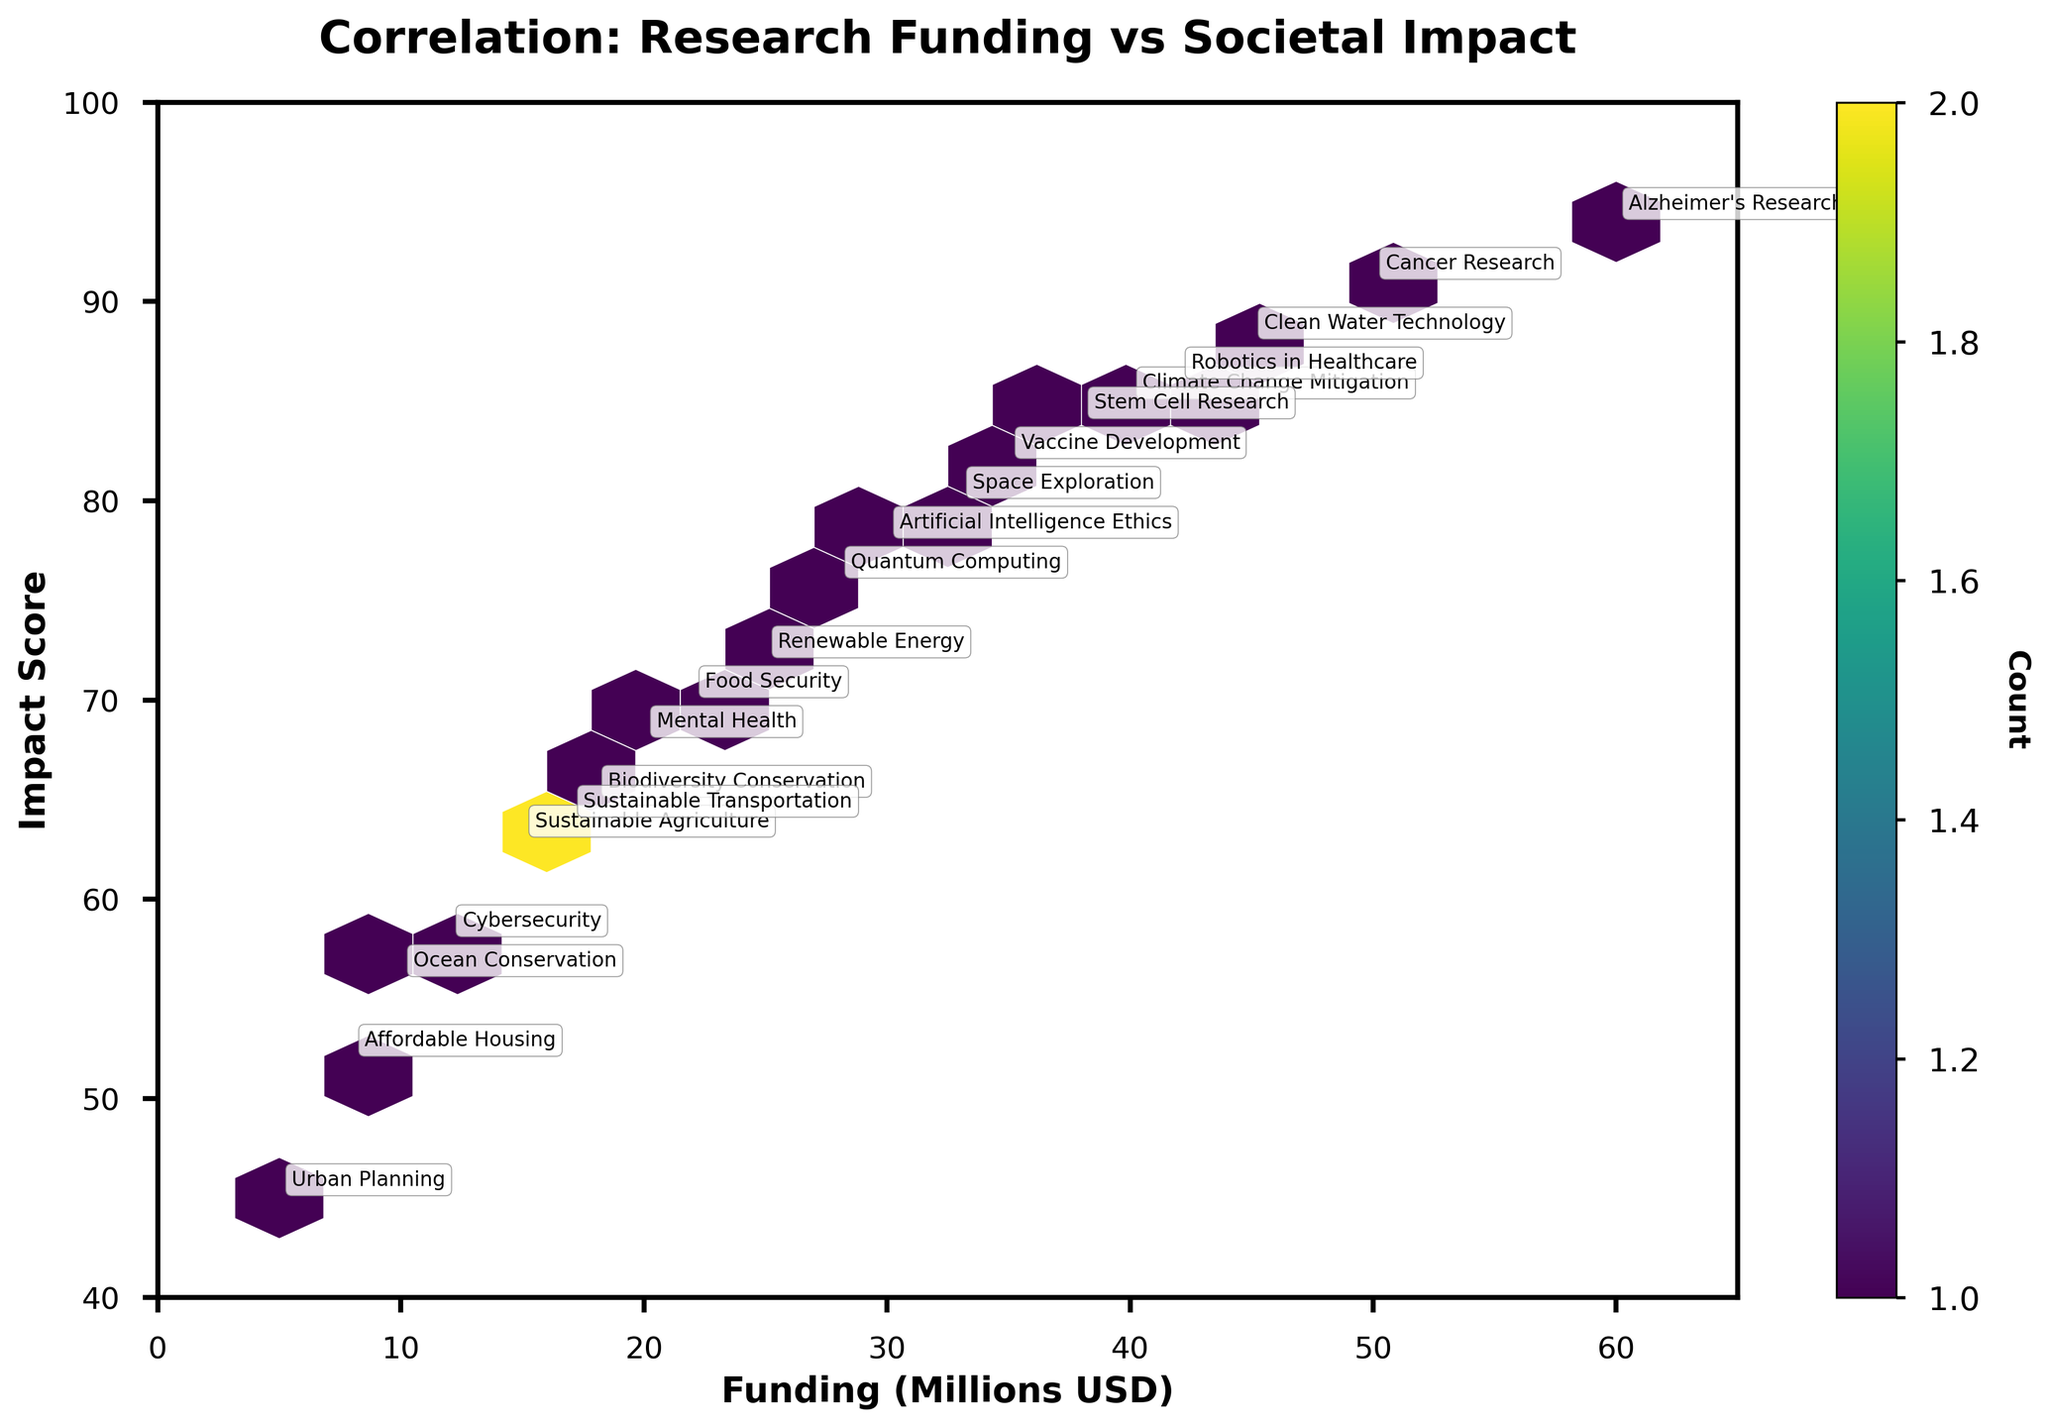What is the title of the plot? The title is displayed prominently at the top of the plot. It contains the text "Correlation: Research Funding vs Societal Impact".
Answer: Correlation: Research Funding vs Societal Impact What are the x and y-axis labels? The labels are positioned along the x and y axes. The x-axis label is "Funding (Millions USD)" and the y-axis label is "Impact Score".
Answer: x-axis: Funding (Millions USD), y-axis: Impact Score How many data points are above an impact score of 90? To determine this, look at the plot area above the y-axis value of 90 and count the number of plotted points. Observing closely, we see there are three data points: Cancer Research, Alzheimer’s Research, and Clean Water Technology.
Answer: 3 Which research field has the highest impact score? Examine the y-axis values and identify the field with the highest y-value. Alzheimer's Research has the highest impact score of 94.
Answer: Alzheimer’s Research Between "Artificial Intelligence Ethics" and "Cybersecurity," which field received more funding? Look at the x-axis values corresponding to these fields. Artificial Intelligence Ethics received 30 million USD in funding, whereas Cybersecurity received 12 million USD.
Answer: Artificial Intelligence Ethics Are there any research fields that have a funding of less than 15 million USD and an impact score greater than 60? Identify any fields where the x-axis value (funding) is less than 15 and the y-axis value (impact score) is greater than 60. Ocean Conservation has a funding of 10 million USD but its impact score is 56, Sustainable Transportation has a funding of 17 million USD and impact score of 64. Cybersecurity has a funding of 12 million and an impact of 58. Therefore, no fields meet both criteria.
Answer: No For the research field "Vaccine Development," what is the count of similarly funded and impactful projects within the same hexbin? The hexbin plot uses hexbins to group data points with a similar range of values; look at the color-coded count and field annotation at "Vaccine Development." Based on the hexbin colors in the vicinity of the Vaccine Development, which is generally an area with similar funding and impact scores, it can be inferred that there is one data point per hexbin cell in this region.
Answer: 1 What is the overall trend between research funding and impact score? Observe the general direction of the data points on the plot: as the funding amount on the x-axis increases, the impact score on the y-axis also generally increases, indicating a positive correlation.
Answer: Positive correlation What research fields cluster around a funding of approximately 40 million USD and an impact score of around 85? Check near the specific funding and impact score values. The research fields clustered around these values are Climate Change Mitigation and Robotics in Healthcare.
Answer: Climate Change Mitigation and Robotics in Healthcare 